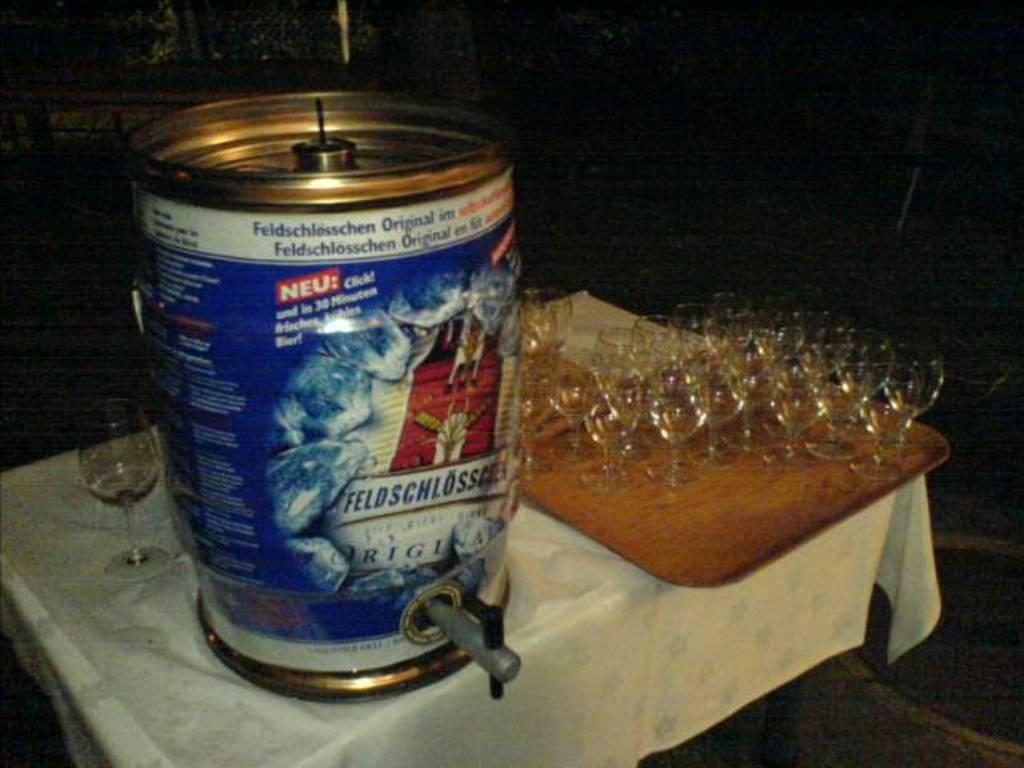<image>
Offer a succinct explanation of the picture presented. A small keg of beer is labeled, Feldschlosschen Original. 